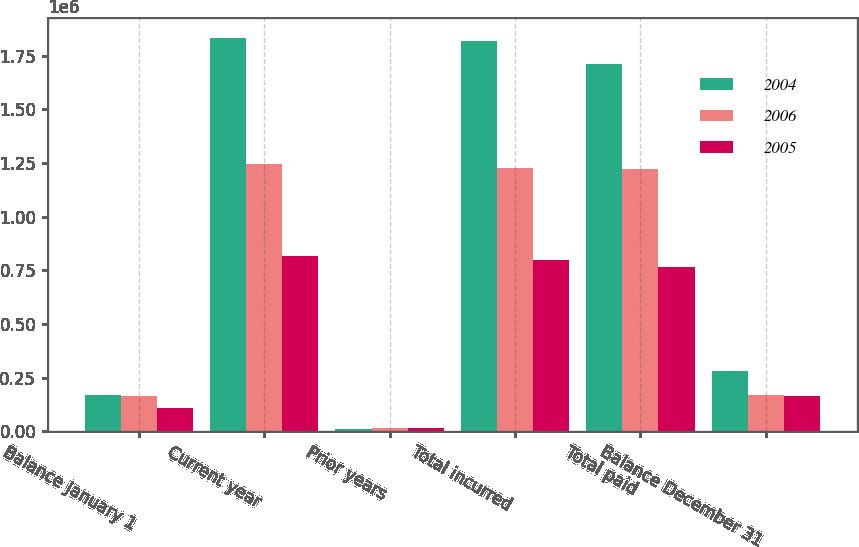Convert chart. <chart><loc_0><loc_0><loc_500><loc_500><stacked_bar_chart><ecel><fcel>Balance January 1<fcel>Current year<fcel>Prior years<fcel>Total incurred<fcel>Total paid<fcel>Balance December 31<nl><fcel>2004<fcel>170514<fcel>1.8321e+06<fcel>12285<fcel>1.81981e+06<fcel>1.71167e+06<fcel>280441<nl><fcel>2006<fcel>165980<fcel>1.2446e+06<fcel>17691<fcel>1.22691e+06<fcel>1.22238e+06<fcel>170514<nl><fcel>2005<fcel>106569<fcel>816418<fcel>15942<fcel>800476<fcel>765974<fcel>165980<nl></chart> 